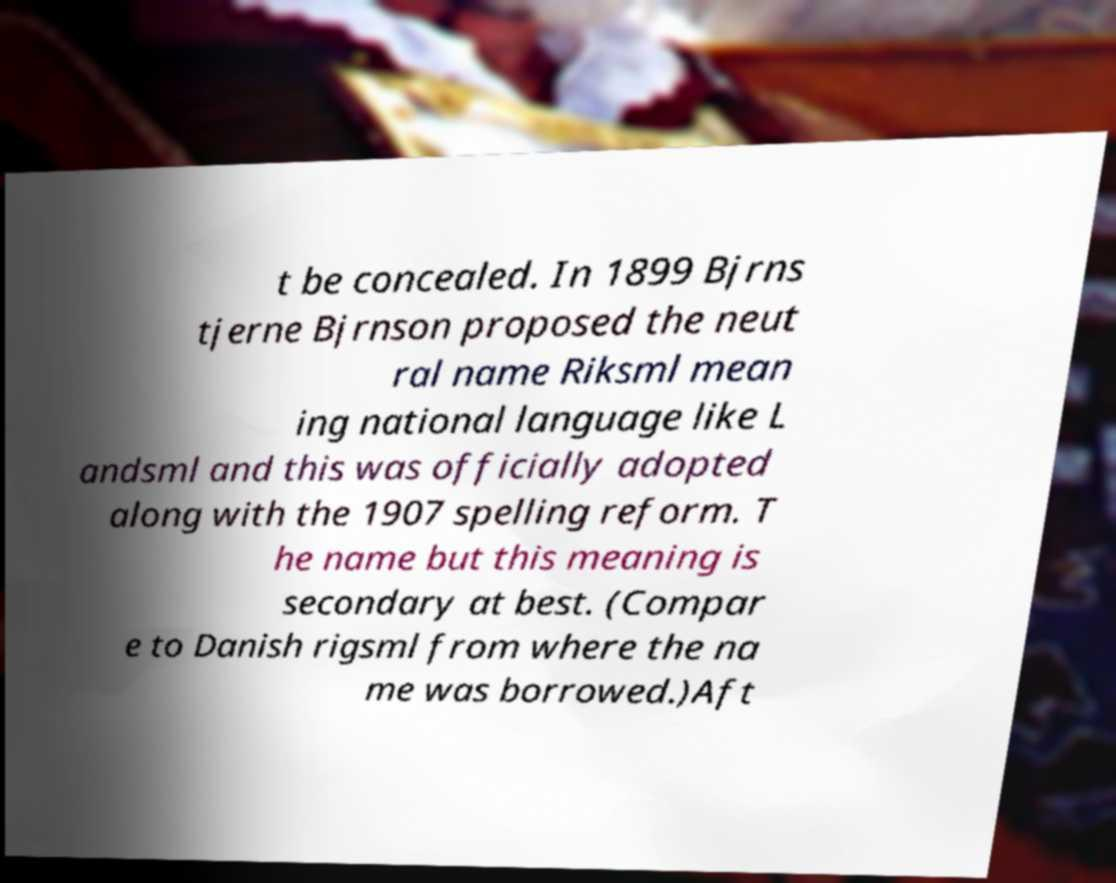Please read and relay the text visible in this image. What does it say? t be concealed. In 1899 Bjrns tjerne Bjrnson proposed the neut ral name Riksml mean ing national language like L andsml and this was officially adopted along with the 1907 spelling reform. T he name but this meaning is secondary at best. (Compar e to Danish rigsml from where the na me was borrowed.)Aft 